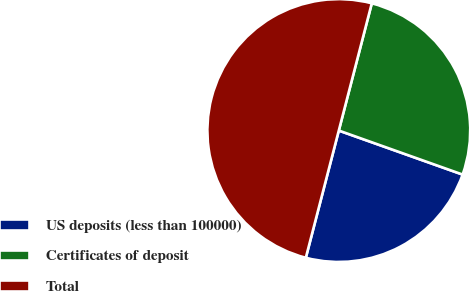Convert chart to OTSL. <chart><loc_0><loc_0><loc_500><loc_500><pie_chart><fcel>US deposits (less than 100000)<fcel>Certificates of deposit<fcel>Total<nl><fcel>23.6%<fcel>26.4%<fcel>50.0%<nl></chart> 